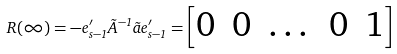Convert formula to latex. <formula><loc_0><loc_0><loc_500><loc_500>R ( \infty ) = - e _ { s - 1 } ^ { \prime } \tilde { A } ^ { - 1 } \tilde { a } e _ { s - 1 } ^ { \prime } = \begin{bmatrix} 0 & 0 & \dots & 0 & 1 \end{bmatrix}</formula> 